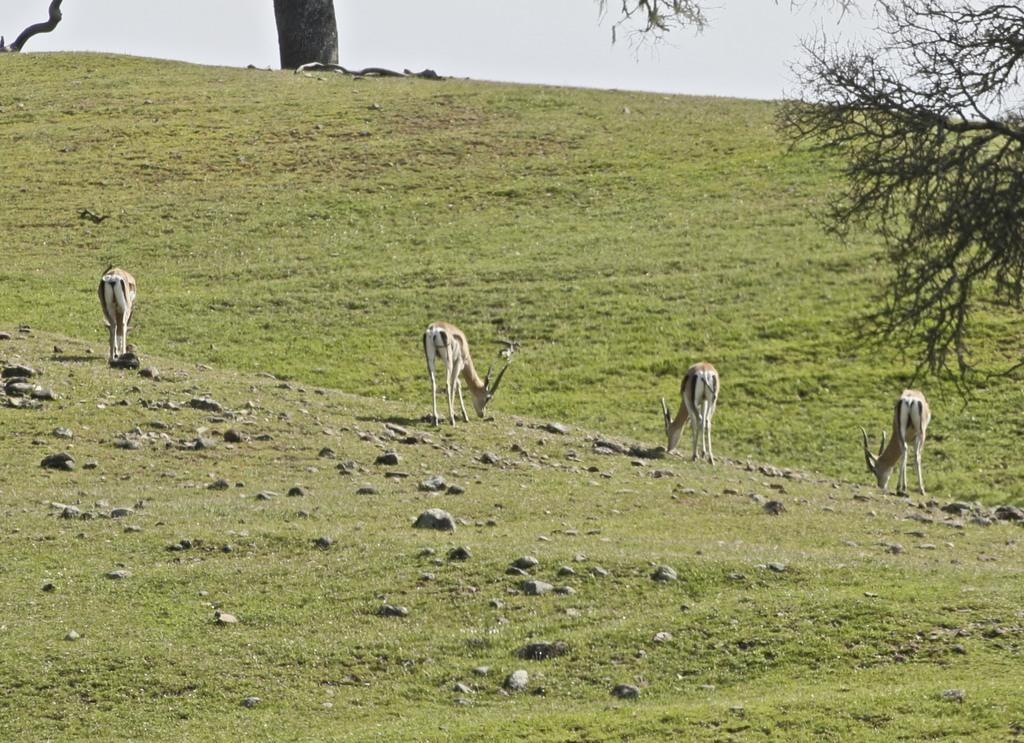What animals are in the foreground of the image? There are deer in the foreground of the image. What type of terrain are the deer on? The deer are on a grassland. What objects can be seen in the image related to trees? There is a trunk and a branch in the image. What is visible at the top of the image? The sky is visible at the top of the image. Are there any other trees visible in the image? Yes, there is another tree on the right side of the image. What type of chair can be seen in the image? There is no chair present in the image. How do the deer stretch in the image? The deer do not stretch in the image; they are standing still on the grassland. 